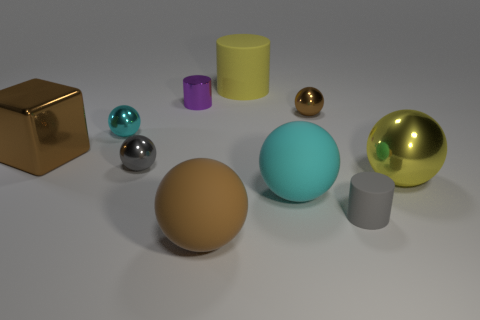Subtract all gray spheres. How many spheres are left? 5 Subtract all brown shiny balls. How many balls are left? 5 Subtract 1 cylinders. How many cylinders are left? 2 Subtract all brown spheres. Subtract all cyan cylinders. How many spheres are left? 4 Subtract all cylinders. How many objects are left? 7 Add 4 green rubber blocks. How many green rubber blocks exist? 4 Subtract 0 brown cylinders. How many objects are left? 10 Subtract all cyan spheres. Subtract all big yellow cylinders. How many objects are left? 7 Add 9 small cyan shiny things. How many small cyan shiny things are left? 10 